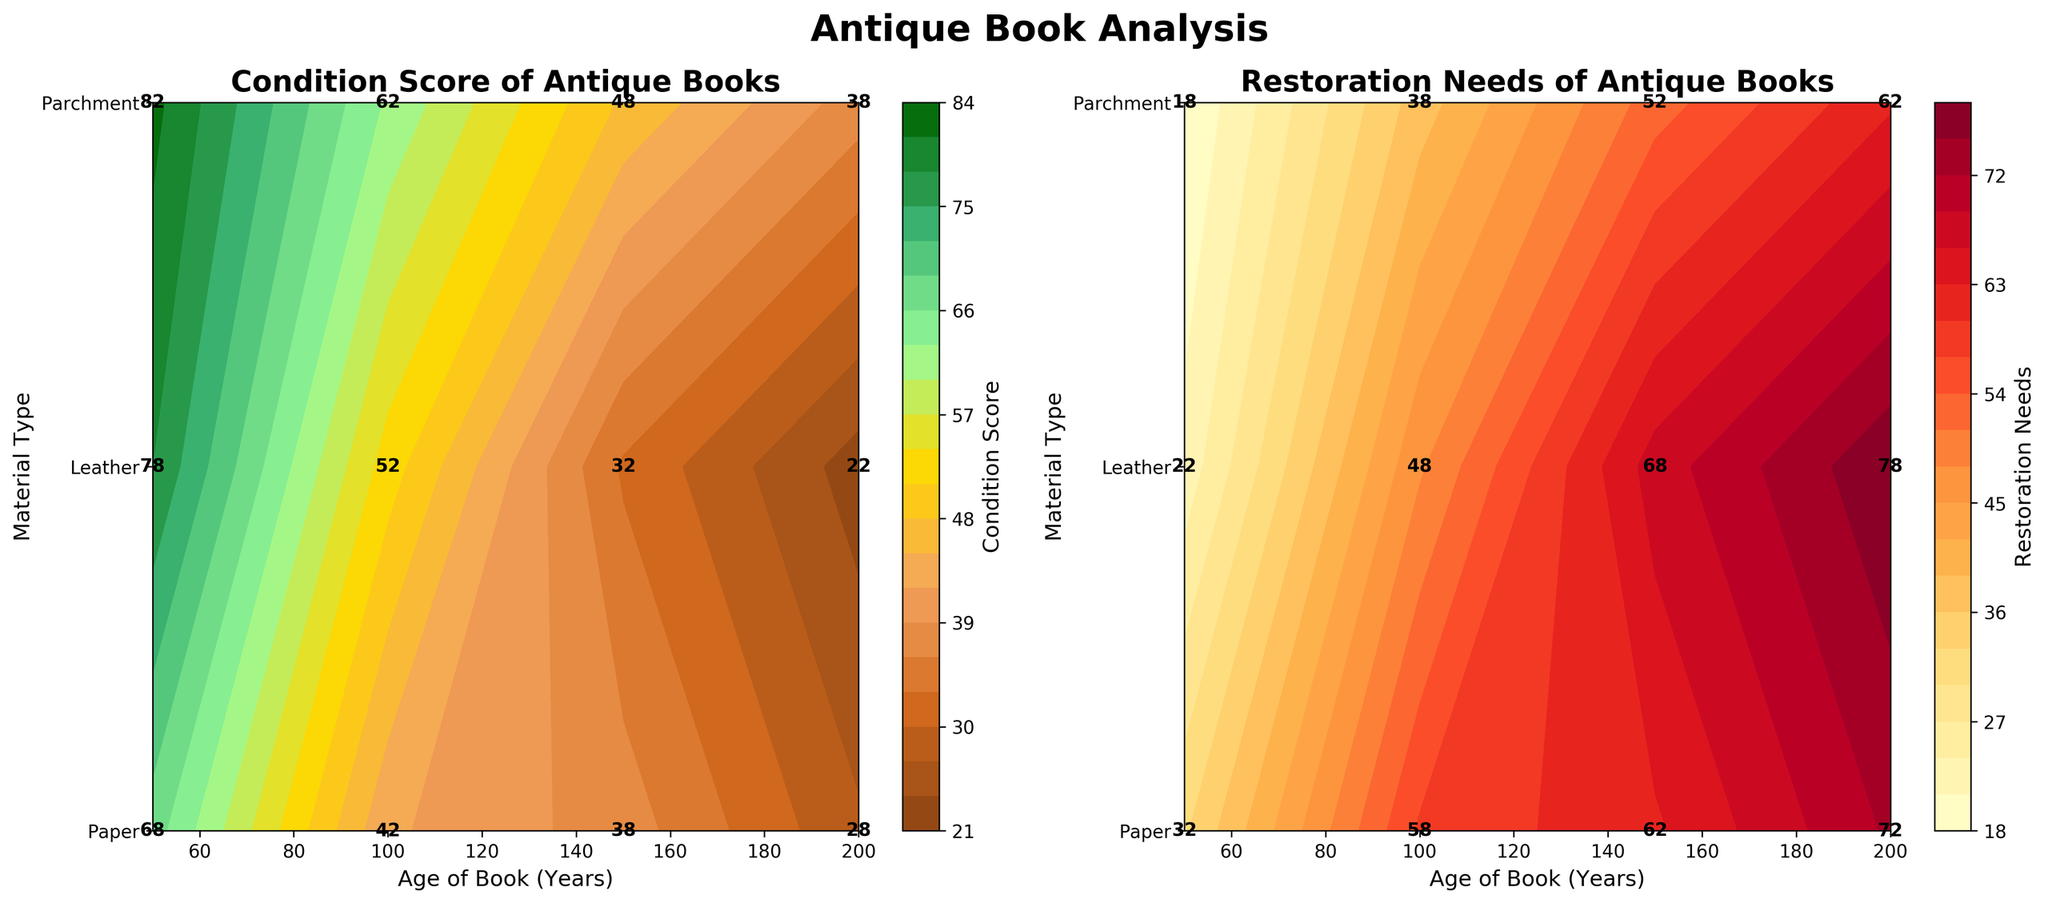What is the title of the left plot? The title of the left plot is "Condition Score of Antique Books". You can find this at the top of the left plot.
Answer: Condition Score of Antique Books How does the Condition Score of books made of parchment change with age? From the plot on the left, you can observe that the Condition Score of parchment books decreases as their age increases. For example, the scores drop from around 82.5 at 50 years to around 37.5 at 200 years.
Answer: Decreases What age and material type combination has the highest Restoration Needs? By analyzing the plot on the right, you can see that the highest Restoration Needs of 80 occurs for leather books aged 200 years.
Answer: Leather, 200 years What is the average Condition Score for leather books aged 50 years and 100 years? From the left plot, the Condition Scores for leather books aged 50 years and 100 years are 76 and 52.5, respectively. The average is calculated as (76 + 52.5) / 2 = 64.25.
Answer: 64.25 Which material type has the highest average Condition Score at 150 years? By inspecting the left plot at the 150-year marker, parchment has the highest average Condition Score of 47.5 compared to leather (32.5) and paper (37.5).
Answer: Parchment Are restoration needs higher for leather or paper books at 200 years? According to the right plot, restoration needs are higher for leather (77.5) compared to paper (72.5) at 200 years.
Answer: Leather What is the Condition Score of paper books at 50 years? The Condition Score of paper books at 50 years is approximately 67.5, as indicated in the left plot.
Answer: 67.5 Between 100 and 150 years, how does the Restoration Needs for leather books change? Looking at the right plot, the Restoration Needs for leather books increase from around 47.5 at 100 years to about 67.5 at 150 years.
Answer: Increases What is the color range used in the Condition Score plot? The color range in the left plot varies from dark brown to dark green, moving through shades of lighter brown and green, representing different Condition Scores.
Answer: Dark brown to dark green 